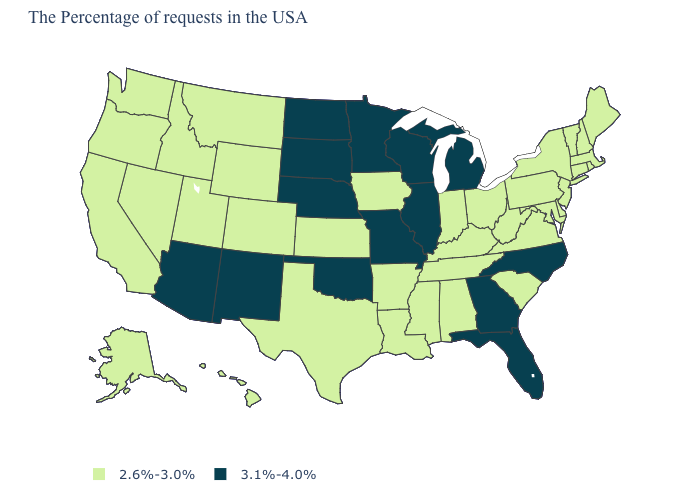What is the value of New Hampshire?
Be succinct. 2.6%-3.0%. Is the legend a continuous bar?
Be succinct. No. What is the value of Georgia?
Quick response, please. 3.1%-4.0%. Does the first symbol in the legend represent the smallest category?
Answer briefly. Yes. Which states have the highest value in the USA?
Give a very brief answer. North Carolina, Florida, Georgia, Michigan, Wisconsin, Illinois, Missouri, Minnesota, Nebraska, Oklahoma, South Dakota, North Dakota, New Mexico, Arizona. What is the value of Ohio?
Give a very brief answer. 2.6%-3.0%. Name the states that have a value in the range 2.6%-3.0%?
Answer briefly. Maine, Massachusetts, Rhode Island, New Hampshire, Vermont, Connecticut, New York, New Jersey, Delaware, Maryland, Pennsylvania, Virginia, South Carolina, West Virginia, Ohio, Kentucky, Indiana, Alabama, Tennessee, Mississippi, Louisiana, Arkansas, Iowa, Kansas, Texas, Wyoming, Colorado, Utah, Montana, Idaho, Nevada, California, Washington, Oregon, Alaska, Hawaii. Does Hawaii have a higher value than North Carolina?
Write a very short answer. No. What is the highest value in states that border Rhode Island?
Quick response, please. 2.6%-3.0%. Does Massachusetts have a lower value than Hawaii?
Give a very brief answer. No. Name the states that have a value in the range 3.1%-4.0%?
Write a very short answer. North Carolina, Florida, Georgia, Michigan, Wisconsin, Illinois, Missouri, Minnesota, Nebraska, Oklahoma, South Dakota, North Dakota, New Mexico, Arizona. Which states have the lowest value in the Northeast?
Write a very short answer. Maine, Massachusetts, Rhode Island, New Hampshire, Vermont, Connecticut, New York, New Jersey, Pennsylvania. Name the states that have a value in the range 3.1%-4.0%?
Give a very brief answer. North Carolina, Florida, Georgia, Michigan, Wisconsin, Illinois, Missouri, Minnesota, Nebraska, Oklahoma, South Dakota, North Dakota, New Mexico, Arizona. 